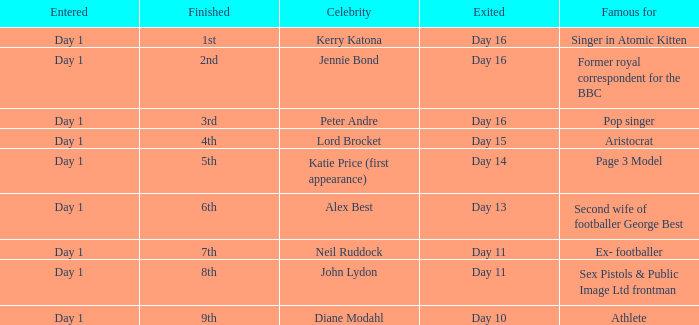Name the number of celebrity for athlete 1.0. 